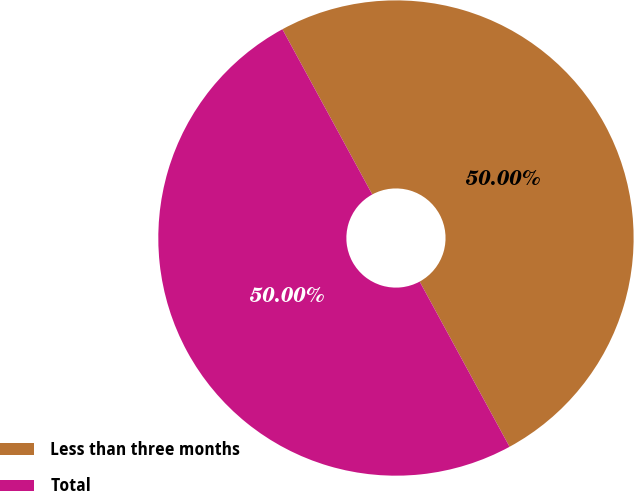Convert chart to OTSL. <chart><loc_0><loc_0><loc_500><loc_500><pie_chart><fcel>Less than three months<fcel>Total<nl><fcel>50.0%<fcel>50.0%<nl></chart> 